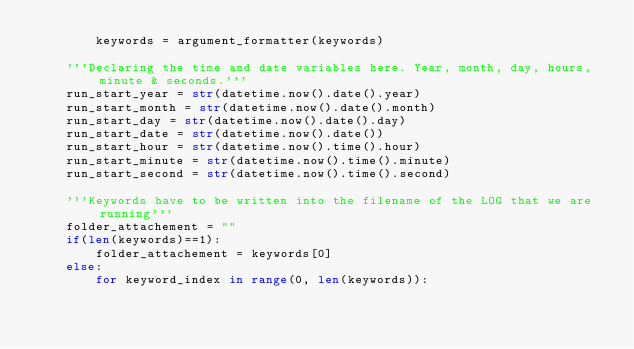Convert code to text. <code><loc_0><loc_0><loc_500><loc_500><_Python_>		keywords = argument_formatter(keywords)

	'''Declaring the time and date variables here. Year, month, day, hours, minute & seconds.'''
	run_start_year = str(datetime.now().date().year)
	run_start_month = str(datetime.now().date().month)
	run_start_day = str(datetime.now().date().day)
	run_start_date = str(datetime.now().date())
	run_start_hour = str(datetime.now().time().hour)
	run_start_minute = str(datetime.now().time().minute)
	run_start_second = str(datetime.now().time().second)

	'''Keywords have to be written into the filename of the LOG that we are running'''
	folder_attachement = ""
	if(len(keywords)==1):
		folder_attachement = keywords[0]
	else:
		for keyword_index in range(0, len(keywords)):</code> 